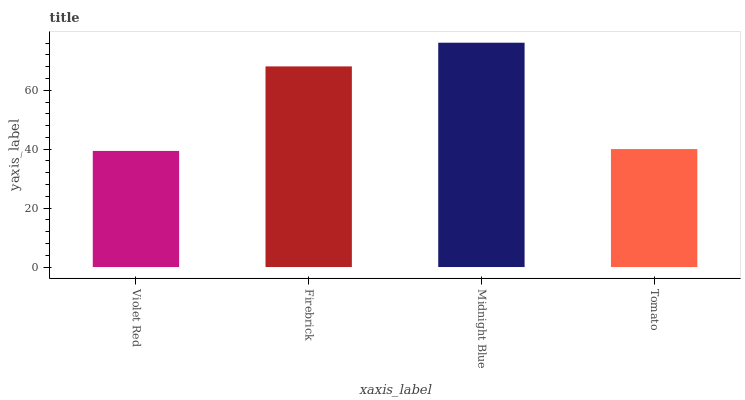Is Firebrick the minimum?
Answer yes or no. No. Is Firebrick the maximum?
Answer yes or no. No. Is Firebrick greater than Violet Red?
Answer yes or no. Yes. Is Violet Red less than Firebrick?
Answer yes or no. Yes. Is Violet Red greater than Firebrick?
Answer yes or no. No. Is Firebrick less than Violet Red?
Answer yes or no. No. Is Firebrick the high median?
Answer yes or no. Yes. Is Tomato the low median?
Answer yes or no. Yes. Is Violet Red the high median?
Answer yes or no. No. Is Violet Red the low median?
Answer yes or no. No. 